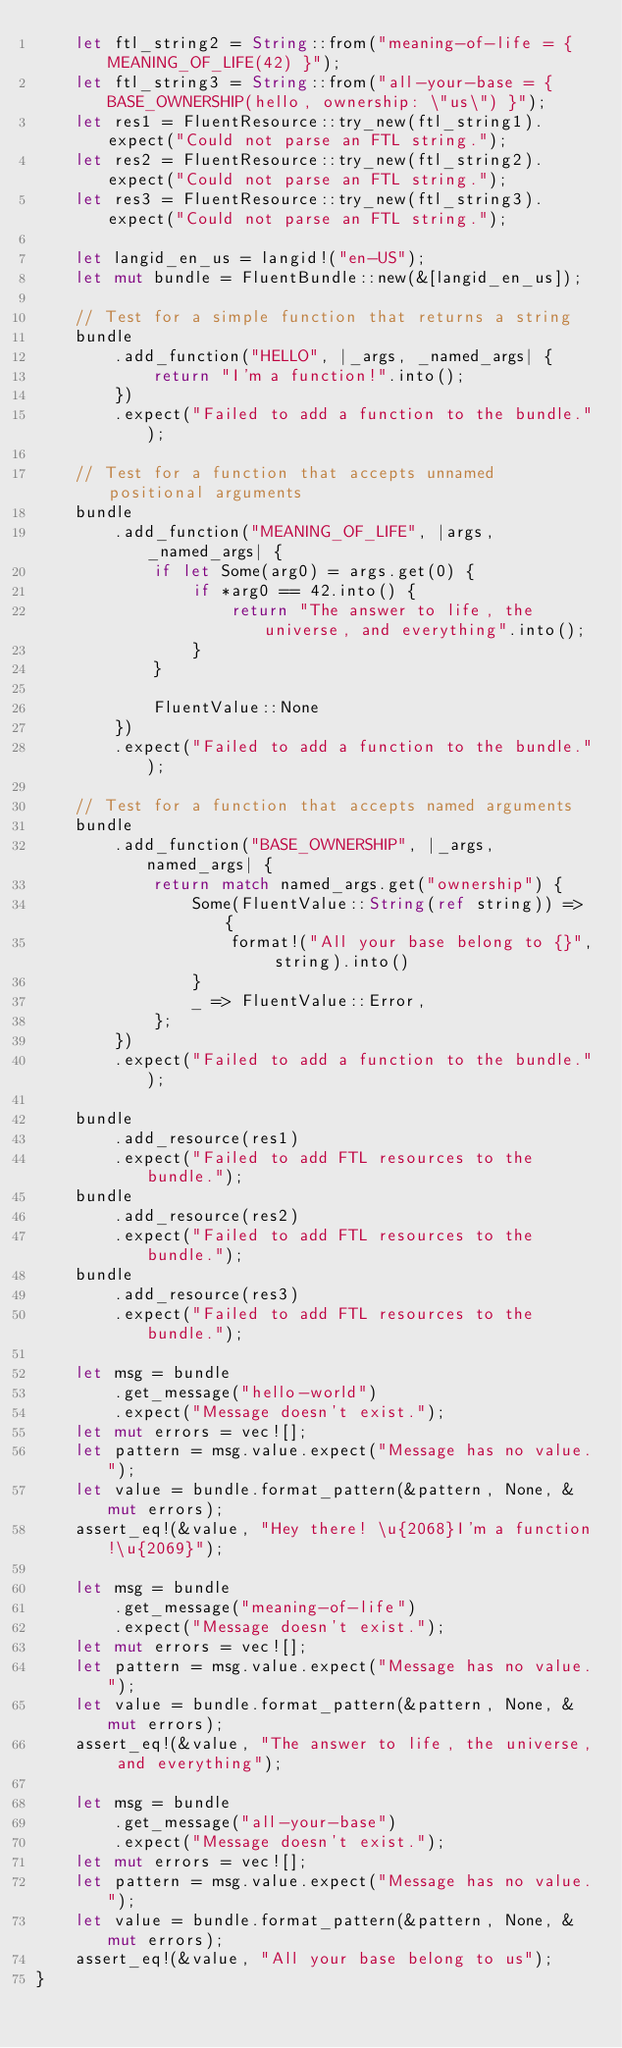<code> <loc_0><loc_0><loc_500><loc_500><_Rust_>    let ftl_string2 = String::from("meaning-of-life = { MEANING_OF_LIFE(42) }");
    let ftl_string3 = String::from("all-your-base = { BASE_OWNERSHIP(hello, ownership: \"us\") }");
    let res1 = FluentResource::try_new(ftl_string1).expect("Could not parse an FTL string.");
    let res2 = FluentResource::try_new(ftl_string2).expect("Could not parse an FTL string.");
    let res3 = FluentResource::try_new(ftl_string3).expect("Could not parse an FTL string.");

    let langid_en_us = langid!("en-US");
    let mut bundle = FluentBundle::new(&[langid_en_us]);

    // Test for a simple function that returns a string
    bundle
        .add_function("HELLO", |_args, _named_args| {
            return "I'm a function!".into();
        })
        .expect("Failed to add a function to the bundle.");

    // Test for a function that accepts unnamed positional arguments
    bundle
        .add_function("MEANING_OF_LIFE", |args, _named_args| {
            if let Some(arg0) = args.get(0) {
                if *arg0 == 42.into() {
                    return "The answer to life, the universe, and everything".into();
                }
            }

            FluentValue::None
        })
        .expect("Failed to add a function to the bundle.");

    // Test for a function that accepts named arguments
    bundle
        .add_function("BASE_OWNERSHIP", |_args, named_args| {
            return match named_args.get("ownership") {
                Some(FluentValue::String(ref string)) => {
                    format!("All your base belong to {}", string).into()
                }
                _ => FluentValue::Error,
            };
        })
        .expect("Failed to add a function to the bundle.");

    bundle
        .add_resource(res1)
        .expect("Failed to add FTL resources to the bundle.");
    bundle
        .add_resource(res2)
        .expect("Failed to add FTL resources to the bundle.");
    bundle
        .add_resource(res3)
        .expect("Failed to add FTL resources to the bundle.");

    let msg = bundle
        .get_message("hello-world")
        .expect("Message doesn't exist.");
    let mut errors = vec![];
    let pattern = msg.value.expect("Message has no value.");
    let value = bundle.format_pattern(&pattern, None, &mut errors);
    assert_eq!(&value, "Hey there! \u{2068}I'm a function!\u{2069}");

    let msg = bundle
        .get_message("meaning-of-life")
        .expect("Message doesn't exist.");
    let mut errors = vec![];
    let pattern = msg.value.expect("Message has no value.");
    let value = bundle.format_pattern(&pattern, None, &mut errors);
    assert_eq!(&value, "The answer to life, the universe, and everything");

    let msg = bundle
        .get_message("all-your-base")
        .expect("Message doesn't exist.");
    let mut errors = vec![];
    let pattern = msg.value.expect("Message has no value.");
    let value = bundle.format_pattern(&pattern, None, &mut errors);
    assert_eq!(&value, "All your base belong to us");
}
</code> 